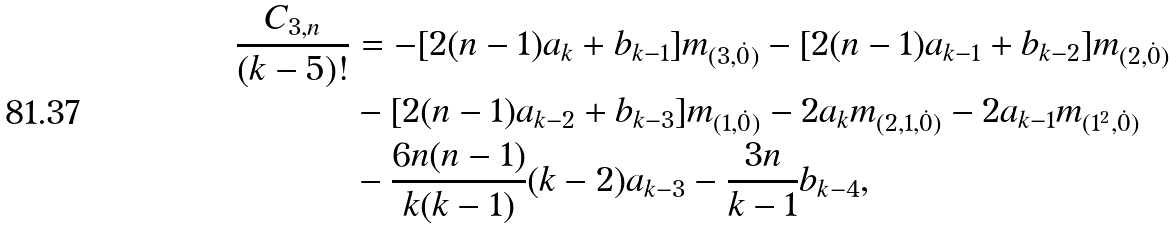Convert formula to latex. <formula><loc_0><loc_0><loc_500><loc_500>\frac { C _ { 3 , n } } { ( k - 5 ) ! } & = - [ 2 ( n - 1 ) a _ { k } + b _ { k - 1 } ] m _ { ( 3 , \dot { 0 } ) } - [ 2 ( n - 1 ) a _ { k - 1 } + b _ { k - 2 } ] m _ { ( 2 , \dot { 0 } ) } \\ & - [ 2 ( n - 1 ) a _ { k - 2 } + b _ { k - 3 } ] m _ { ( 1 , \dot { 0 } ) } - 2 a _ { k } m _ { ( 2 , 1 , \dot { 0 } ) } - 2 a _ { k - 1 } m _ { ( 1 ^ { 2 } , \dot { 0 } ) } \\ & - \frac { 6 n ( n - 1 ) } { k ( k - 1 ) } ( k - 2 ) a _ { k - 3 } - \frac { 3 n } { k - 1 } b _ { k - 4 } ,</formula> 